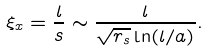<formula> <loc_0><loc_0><loc_500><loc_500>\xi _ { x } = \frac { l } { s } \sim \frac { l } { \sqrt { r _ { s } } \ln ( l / a ) } .</formula> 